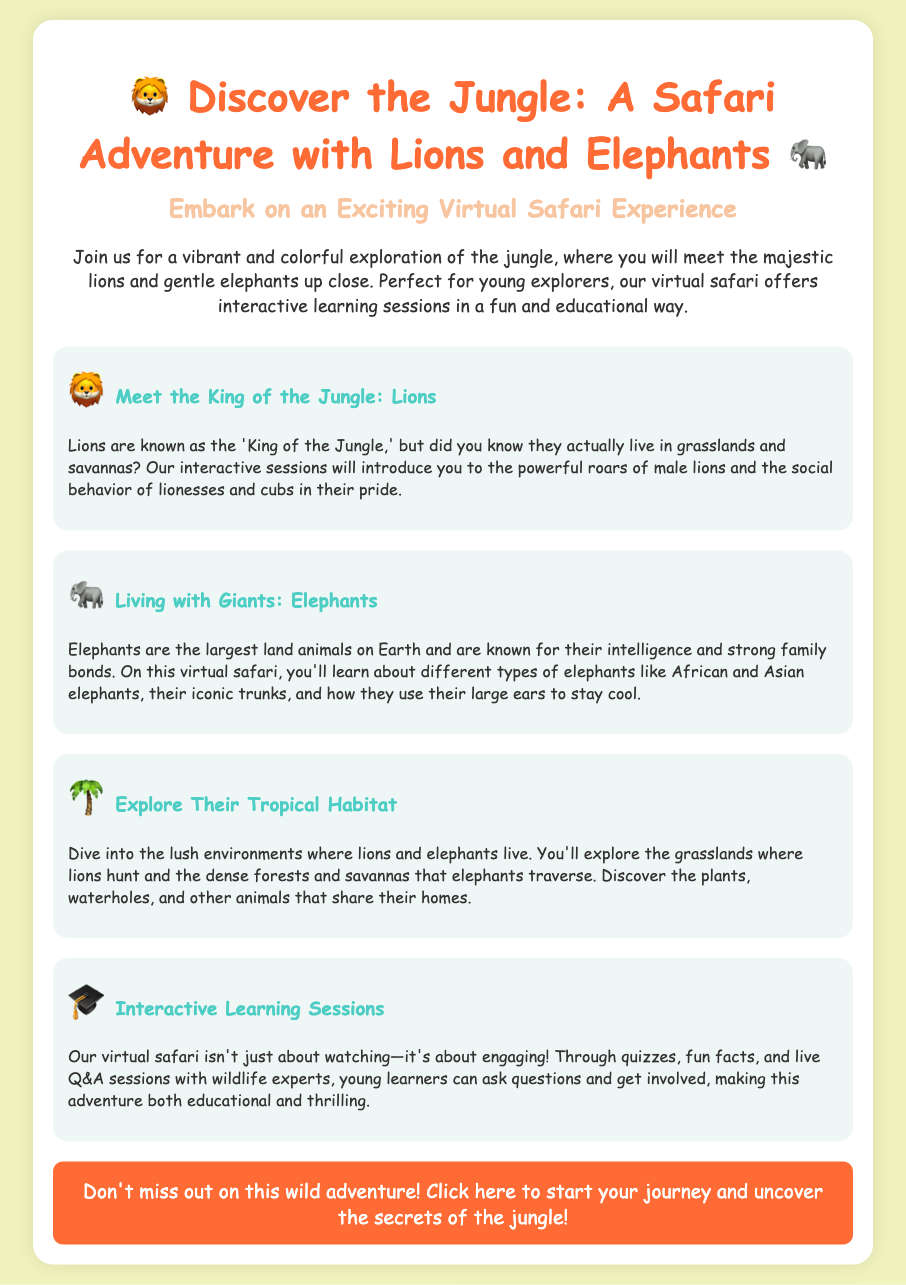What animals can you meet on the safari? The advertisement mentions two animals you will meet: lions and elephants.
Answer: lions and elephants What type of habitat do lions actually live in? It states that lions live in grasslands and savannas, not jungles.
Answer: grasslands and savannas What are elephants known for? The advertisement highlights that elephants are known for their intelligence and strong family bonds.
Answer: intelligence and strong family bonds What type of learning sessions are included in the virtual safari? The document describes the interactive learning sessions, which involve quizzes, fun facts, and live Q&A sessions.
Answer: interactive learning sessions What is the main attraction of the safari? The main attraction is to explore and learn about lions and elephants in a virtual setting.
Answer: explore and learn about lions and elephants How many types of elephants are mentioned? The advertisement mentions two types of elephants.
Answer: two types What kind of environment will children explore? The document describes a tropical habitat, specifically mentioning lush environments where lions and elephants live.
Answer: tropical habitat What can young learners do during the interactive learning sessions? Young learners can ask questions and get involved, making the learning experience engaging.
Answer: ask questions and get involved What does the “Don’t miss out on this wild adventure!” call to action encourage? The call to action encourages readers to click and start their virtual safari journey.
Answer: click and start their journey 